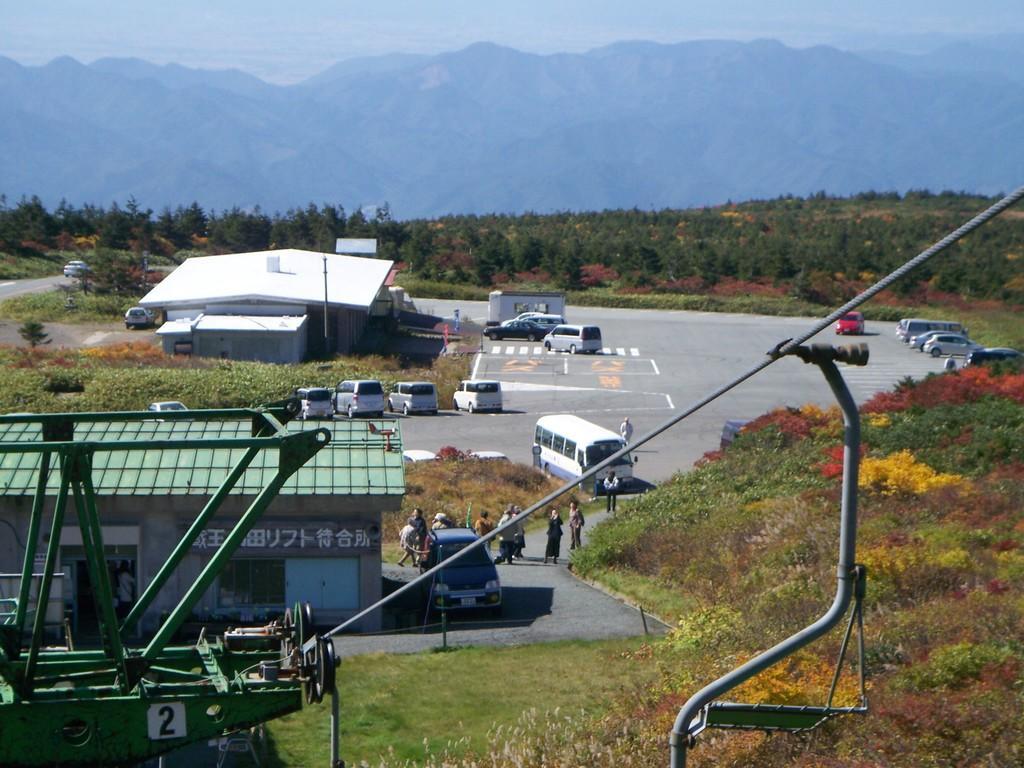Describe this image in one or two sentences. In this image we can see some vehicles, sheds, plants, trees, mountains, rope, poles, also we can see the sky. 